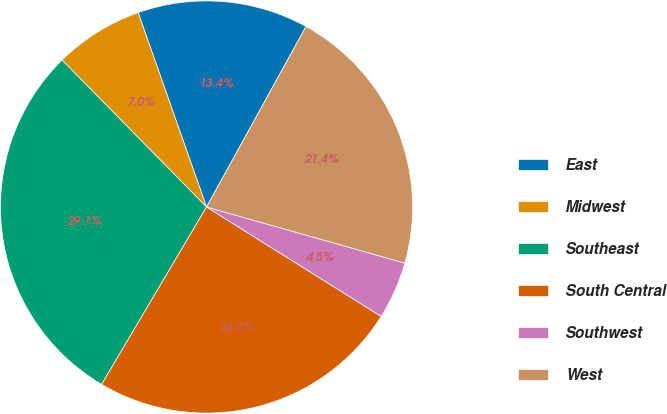Convert chart to OTSL. <chart><loc_0><loc_0><loc_500><loc_500><pie_chart><fcel>East<fcel>Midwest<fcel>Southeast<fcel>South Central<fcel>Southwest<fcel>West<nl><fcel>13.4%<fcel>6.98%<fcel>29.13%<fcel>24.59%<fcel>4.52%<fcel>21.37%<nl></chart> 